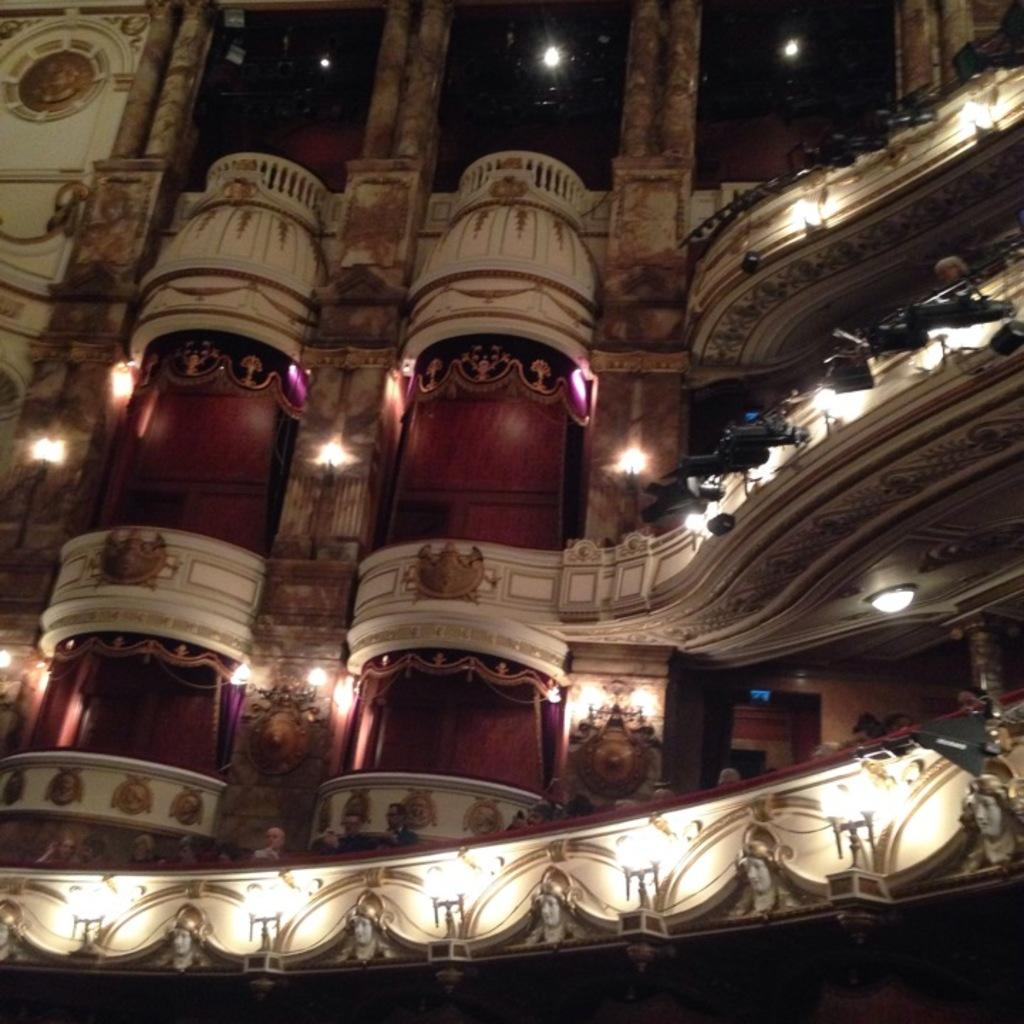What type of structure is present in the image? There is a building in the image. What distinguishes the building from other structures? The building has carvings on it. What can be seen illuminated in the image? There are lights visible in the image. Are there any living beings present in the image? Yes, there are people in the image. What type of church can be seen in the image? There is no church present in the image; it features a building with carvings. Is there a baseball game taking place in the image? There is no baseball game or any reference to sports in the image. 